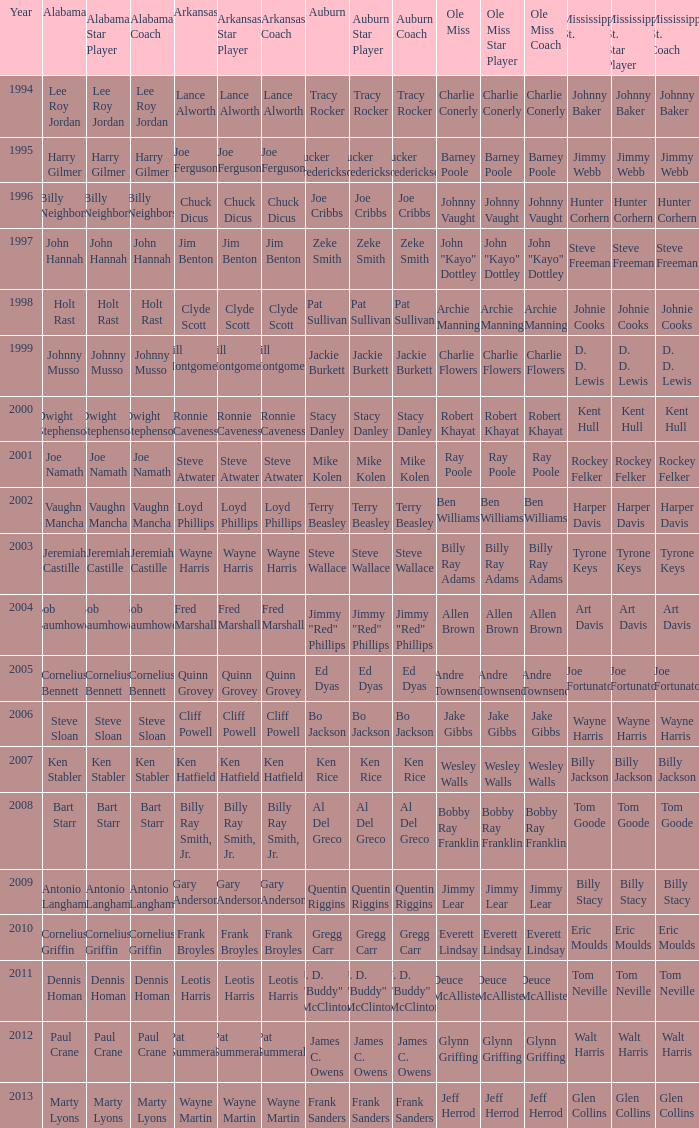Who was the player associated with Ole Miss in years after 2008 with a Mississippi St. name of Eric Moulds? Everett Lindsay. 